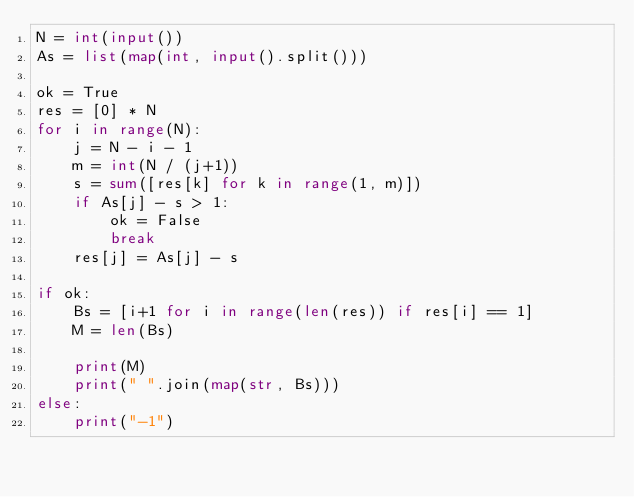Convert code to text. <code><loc_0><loc_0><loc_500><loc_500><_Python_>N = int(input())
As = list(map(int, input().split()))

ok = True
res = [0] * N
for i in range(N):
    j = N - i - 1
    m = int(N / (j+1))
    s = sum([res[k] for k in range(1, m)])
    if As[j] - s > 1:
        ok = False
        break
    res[j] = As[j] - s

if ok:
    Bs = [i+1 for i in range(len(res)) if res[i] == 1] 
    M = len(Bs)

    print(M)
    print(" ".join(map(str, Bs)))
else:
    print("-1")</code> 